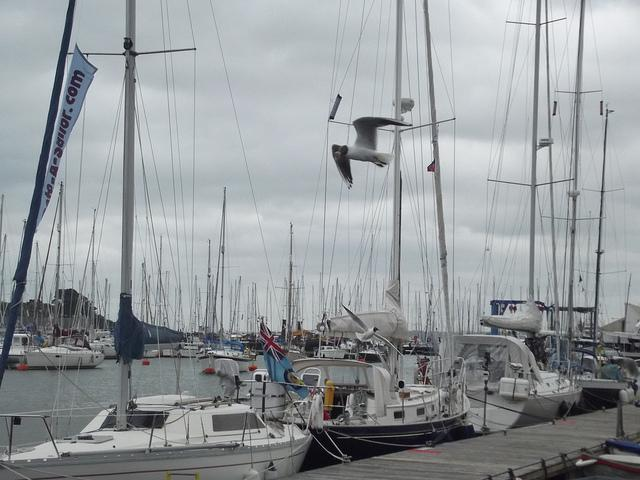What baby name is related to this place?

Choices:
A) dell
B) shemp
C) apple
D) marina marina 